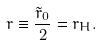<formula> <loc_0><loc_0><loc_500><loc_500>r \equiv \frac { \tilde { r } _ { 0 } } { 2 } = r _ { H } .</formula> 